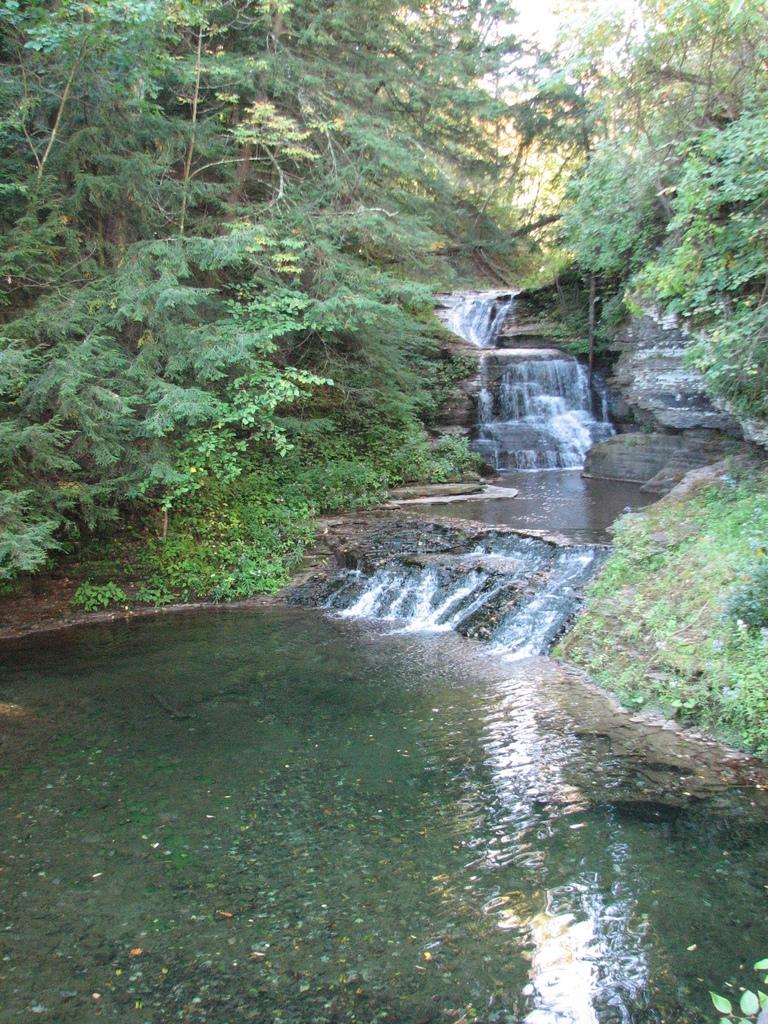What is visible in the image? Water, rocks, and trees are visible in the image. Can you describe the natural environment in the image? The image features a natural environment with water, rocks, and trees. What type of vegetation is present in the image? Trees are present in the image. What type of society can be seen interacting with the trees in the image? There is no society present in the image; it features water, rocks, and trees in a natural environment. How does the mind of the water interact with the rocks in the image? The image does not depict the mind of the water or any interaction with the rocks; it simply shows water, rocks, and trees. 